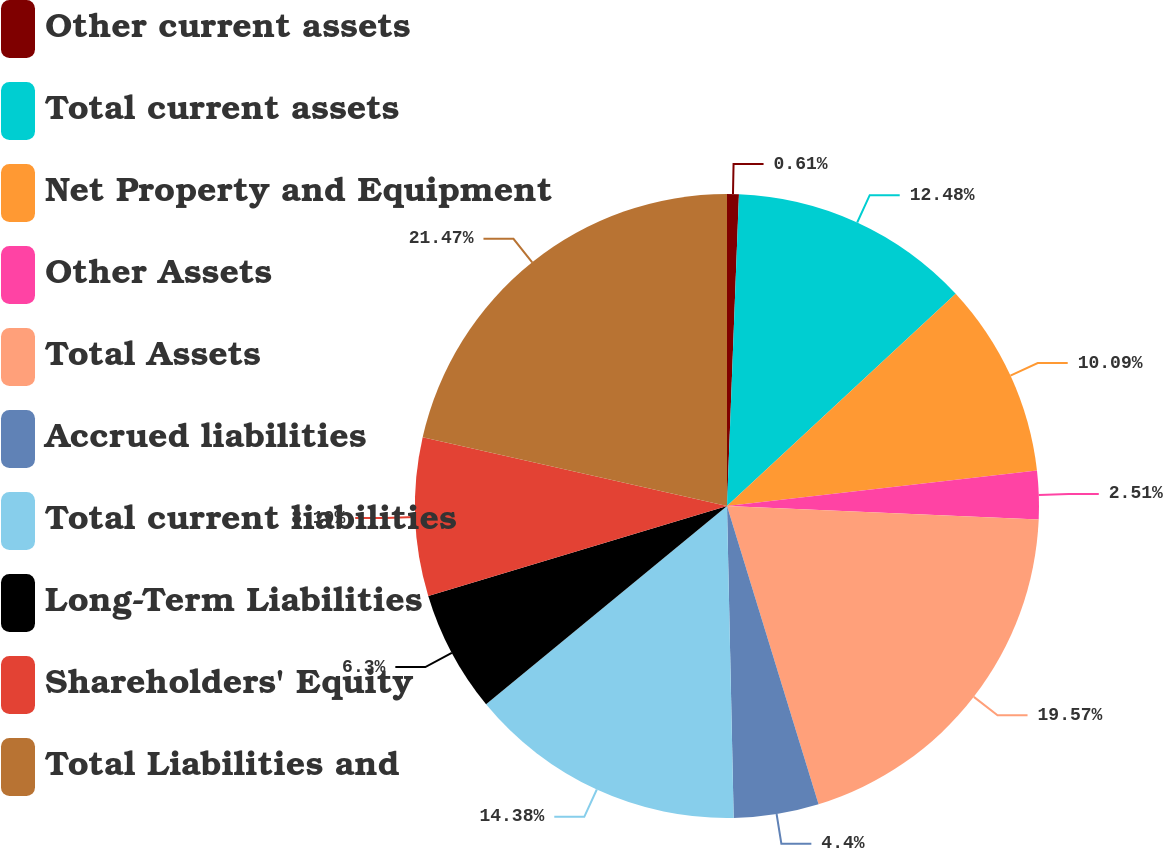<chart> <loc_0><loc_0><loc_500><loc_500><pie_chart><fcel>Other current assets<fcel>Total current assets<fcel>Net Property and Equipment<fcel>Other Assets<fcel>Total Assets<fcel>Accrued liabilities<fcel>Total current liabilities<fcel>Long-Term Liabilities<fcel>Shareholders' Equity<fcel>Total Liabilities and<nl><fcel>0.61%<fcel>12.48%<fcel>10.09%<fcel>2.51%<fcel>19.56%<fcel>4.4%<fcel>14.38%<fcel>6.3%<fcel>8.19%<fcel>21.46%<nl></chart> 